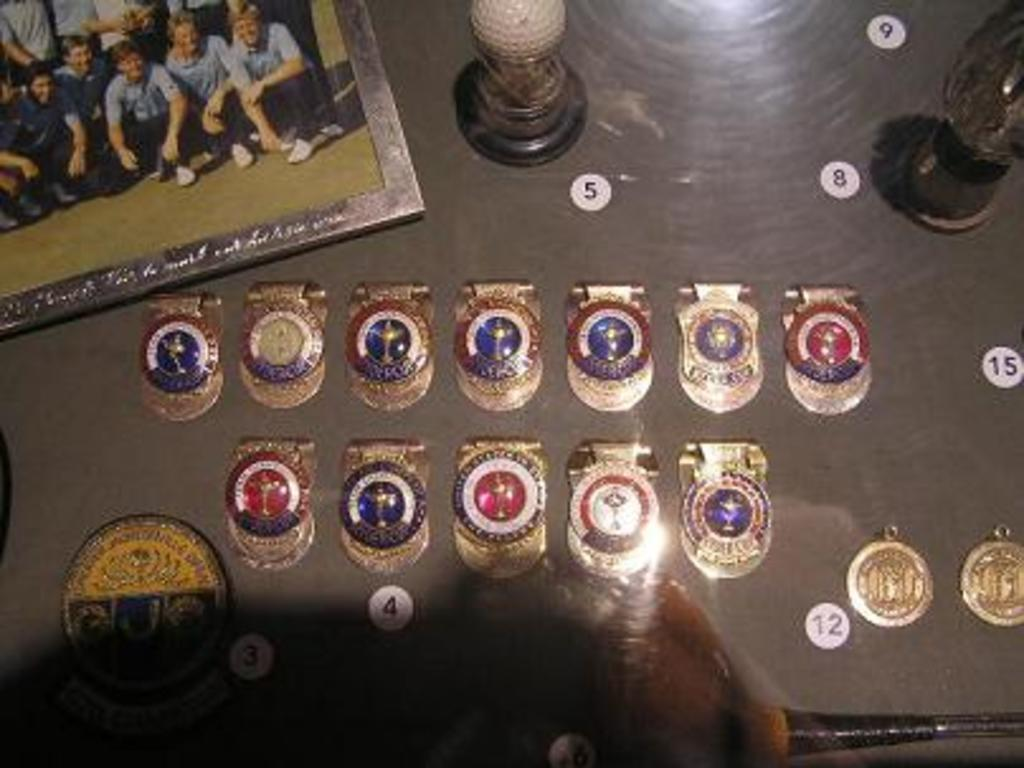<image>
Render a clear and concise summary of the photo. A board has numbers up to 15 in white circles on it. 